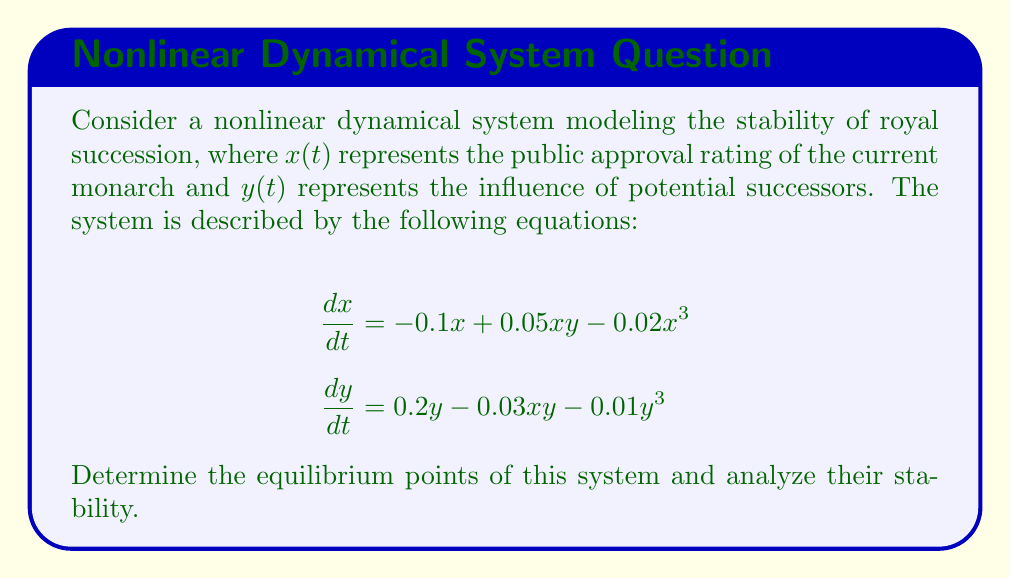What is the answer to this math problem? 1) To find the equilibrium points, set both equations to zero:

   $$-0.1x + 0.05xy - 0.02x^3 = 0$$
   $$0.2y - 0.03xy - 0.01y^3 = 0$$

2) Trivial equilibrium point: $(0,0)$

3) For non-trivial equilibrium points, factor out $x$ and $y$ from each equation:

   $$x(-0.1 + 0.05y - 0.02x^2) = 0$$
   $$y(0.2 - 0.03x - 0.01y^2) = 0$$

4) Solving these simultaneously yields three more equilibrium points:
   $(0, \sqrt{20})$, $(5, 0)$, and $(5, \sqrt{5})$

5) To analyze stability, we need to compute the Jacobian matrix:

   $$J = \begin{bmatrix}
   -0.1 + 0.05y - 0.06x^2 & 0.05x \\
   -0.03y & 0.2 - 0.03x - 0.03y^2
   \end{bmatrix}$$

6) Evaluate the Jacobian at each equilibrium point:

   At $(0,0)$: $J = \begin{bmatrix} -0.1 & 0 \\ 0 & 0.2 \end{bmatrix}$
   Eigenvalues: $-0.1$ and $0.2$. This is an unstable saddle point.

   At $(0, \sqrt{20})$: $J = \begin{bmatrix} 0.9 & 0 \\ -0.3\sqrt{20} & -0.4 \end{bmatrix}$
   Eigenvalues: $0.9$ and $-0.4$. This is an unstable saddle point.

   At $(5, 0)$: $J = \begin{bmatrix} -1.6 & 0.25 \\ 0 & 0.05 \end{bmatrix}$
   Eigenvalues: $-1.6$ and $0.05$. This is an unstable saddle point.

   At $(5, \sqrt{5})$: $J = \begin{bmatrix} -1.35 & 0.25 \\ -0.3\sqrt{5} & -0.1 \end{bmatrix}$
   Eigenvalues: $-1.4038$ and $-0.0462$. This is a stable node.

7) The stable equilibrium point $(5, \sqrt{5})$ represents a balance between the current monarch's approval and the influence of successors, ensuring stable royal succession.
Answer: The system has four equilibrium points: $(0,0)$, $(0, \sqrt{20})$, $(5, 0)$, and $(5, \sqrt{5})$. Only $(5, \sqrt{5})$ is stable, representing balanced royal succession. 